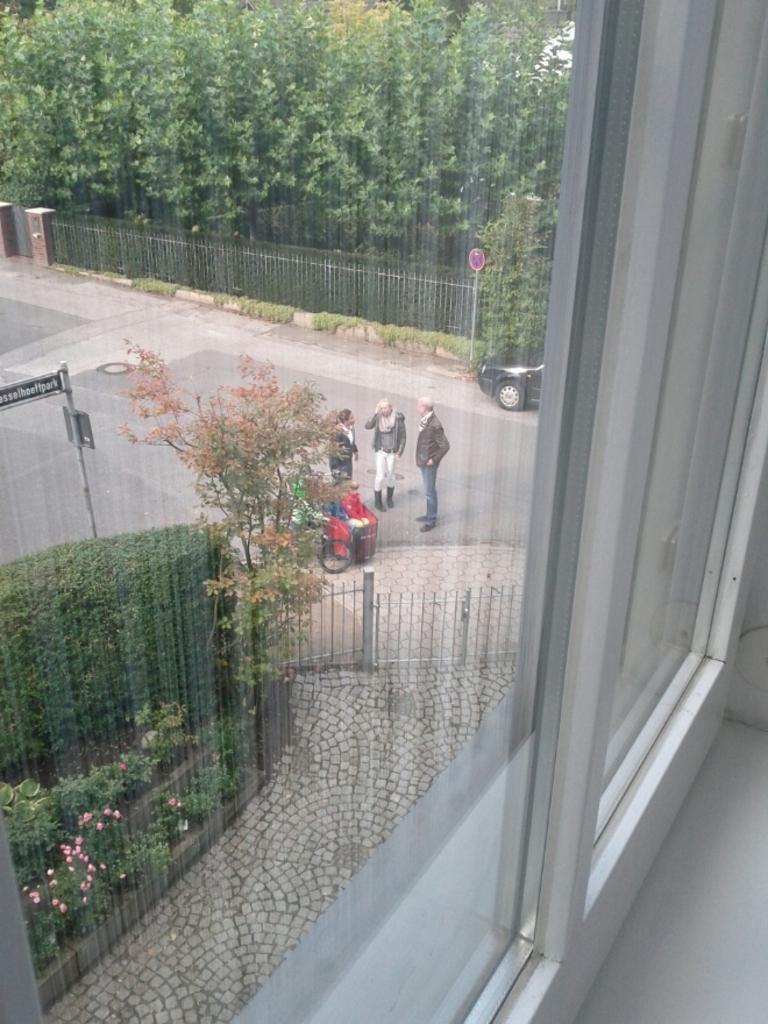Can you describe this image briefly? In this image we can see a window, through the window there are people and vehicles on the road. And we can see the plants, flowers, trees, fence and boards. 